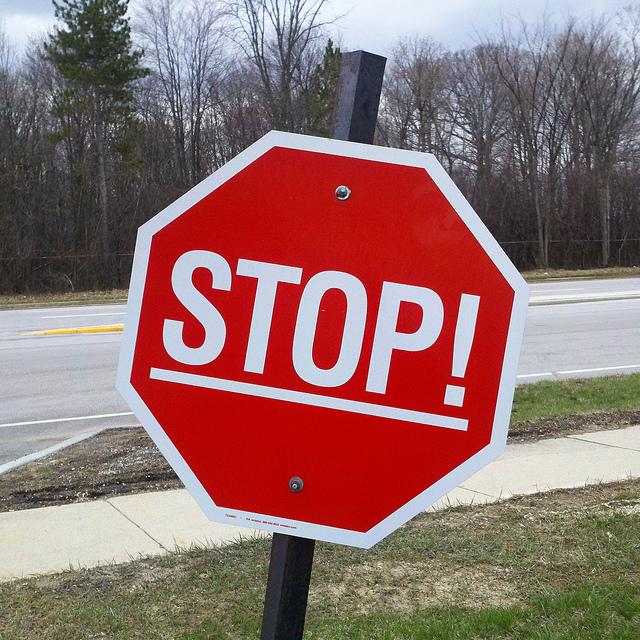How many screws are attached to the sign?
Be succinct. 2. What color is the sign?
Short answer required. Red. Is there grass in the background?
Write a very short answer. Yes. Is this a color photo?
Concise answer only. Yes. Is the sign placed too far down the pole?
Be succinct. Yes. 